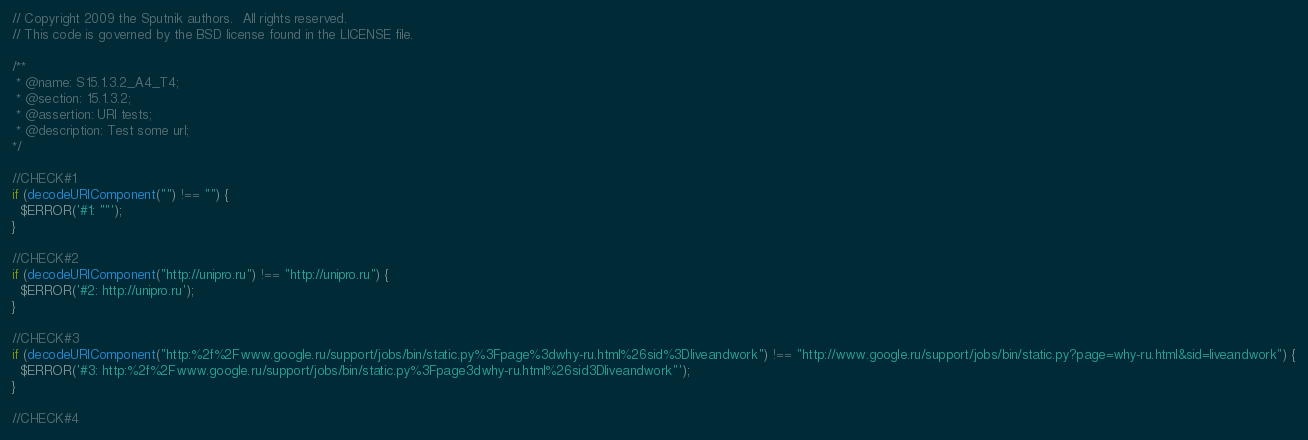Convert code to text. <code><loc_0><loc_0><loc_500><loc_500><_JavaScript_>// Copyright 2009 the Sputnik authors.  All rights reserved.
// This code is governed by the BSD license found in the LICENSE file.

/**
 * @name: S15.1.3.2_A4_T4;
 * @section: 15.1.3.2;
 * @assertion: URI tests;
 * @description: Test some url;
*/

//CHECK#1
if (decodeURIComponent("") !== "") {
  $ERROR('#1: ""');
}

//CHECK#2
if (decodeURIComponent("http://unipro.ru") !== "http://unipro.ru") {
  $ERROR('#2: http://unipro.ru');
}

//CHECK#3
if (decodeURIComponent("http:%2f%2Fwww.google.ru/support/jobs/bin/static.py%3Fpage%3dwhy-ru.html%26sid%3Dliveandwork") !== "http://www.google.ru/support/jobs/bin/static.py?page=why-ru.html&sid=liveandwork") {
  $ERROR('#3: http:%2f%2Fwww.google.ru/support/jobs/bin/static.py%3Fpage3dwhy-ru.html%26sid3Dliveandwork"');
}           

//CHECK#4</code> 